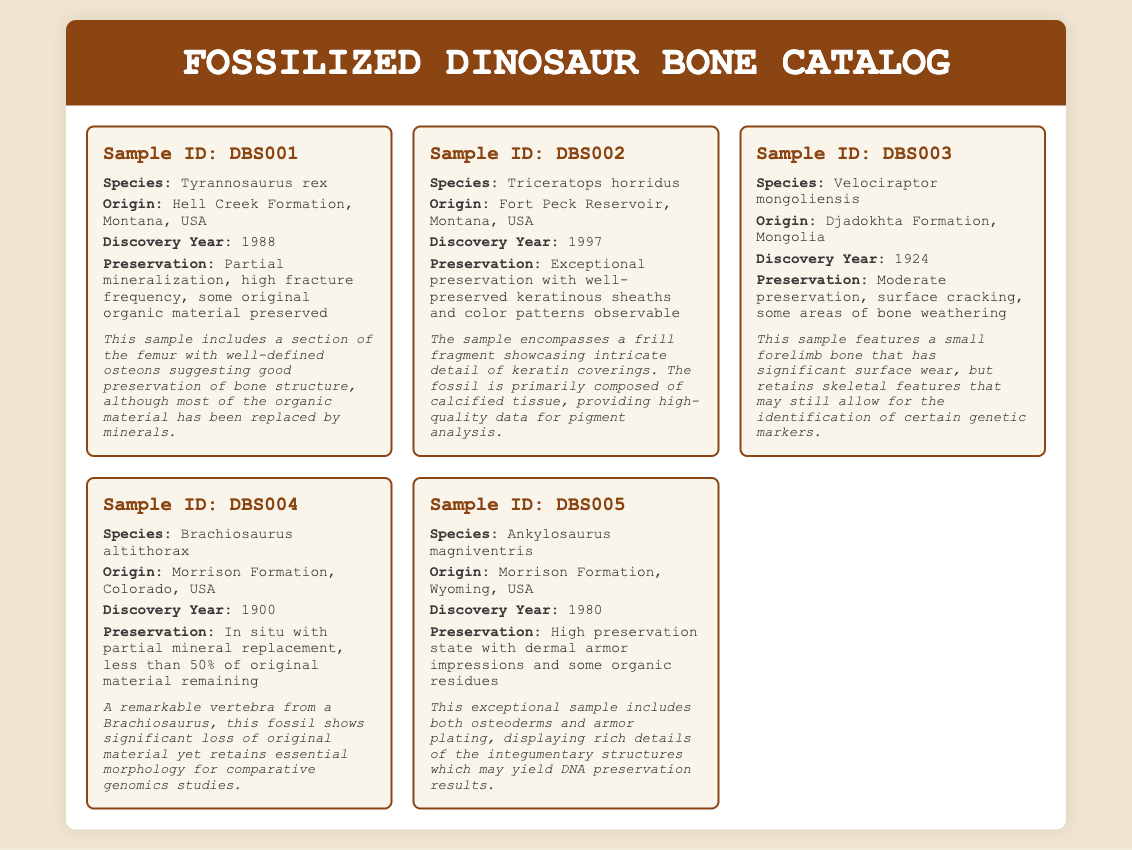What is the sample ID for Tyrannosaurus rex? The sample ID for Tyrannosaurus rex is mentioned in the document under the specific entry for that species.
Answer: DBS001 Where was the Triceratops horridus sample found? The geographic origin of the Triceratops horridus sample is stated in the description of that sample.
Answer: Fort Peck Reservoir, Montana, USA What year was the Velociraptor mongoliensis sample discovered? The discovery year for Velociraptor mongoliensis is provided in its sample details section.
Answer: 1924 What preservation state is indicated for the Ankylosaurus magniventris sample? The preservation condition for the Ankylosaurus magniventris can be found in the relevant entry describing that sample.
Answer: High preservation state Which dinosaur species had exceptional preservation of color patterns? The species with exceptional preservation is identified in the sample details concerning the condition of the fossil.
Answer: Triceratops horridus What is the significant feature of the femur in the Tyrannosaurus rex sample? The notable aspect of the femur in the Tyrannosaurus rex description highlights a specific characteristic related to its preservation.
Answer: Well-defined osteons What is the mineralization condition of the Brachiosaurus altithorax sample? The preservation description for Brachiosaurus altithorax includes details about the mineralization state of the fossil.
Answer: Partial mineral replacement Which sample includes dermal armor impressions? The sample with dermal armor impressions is indicated in the context of the related dinosaur species.
Answer: Ankylosaurus magniventris 